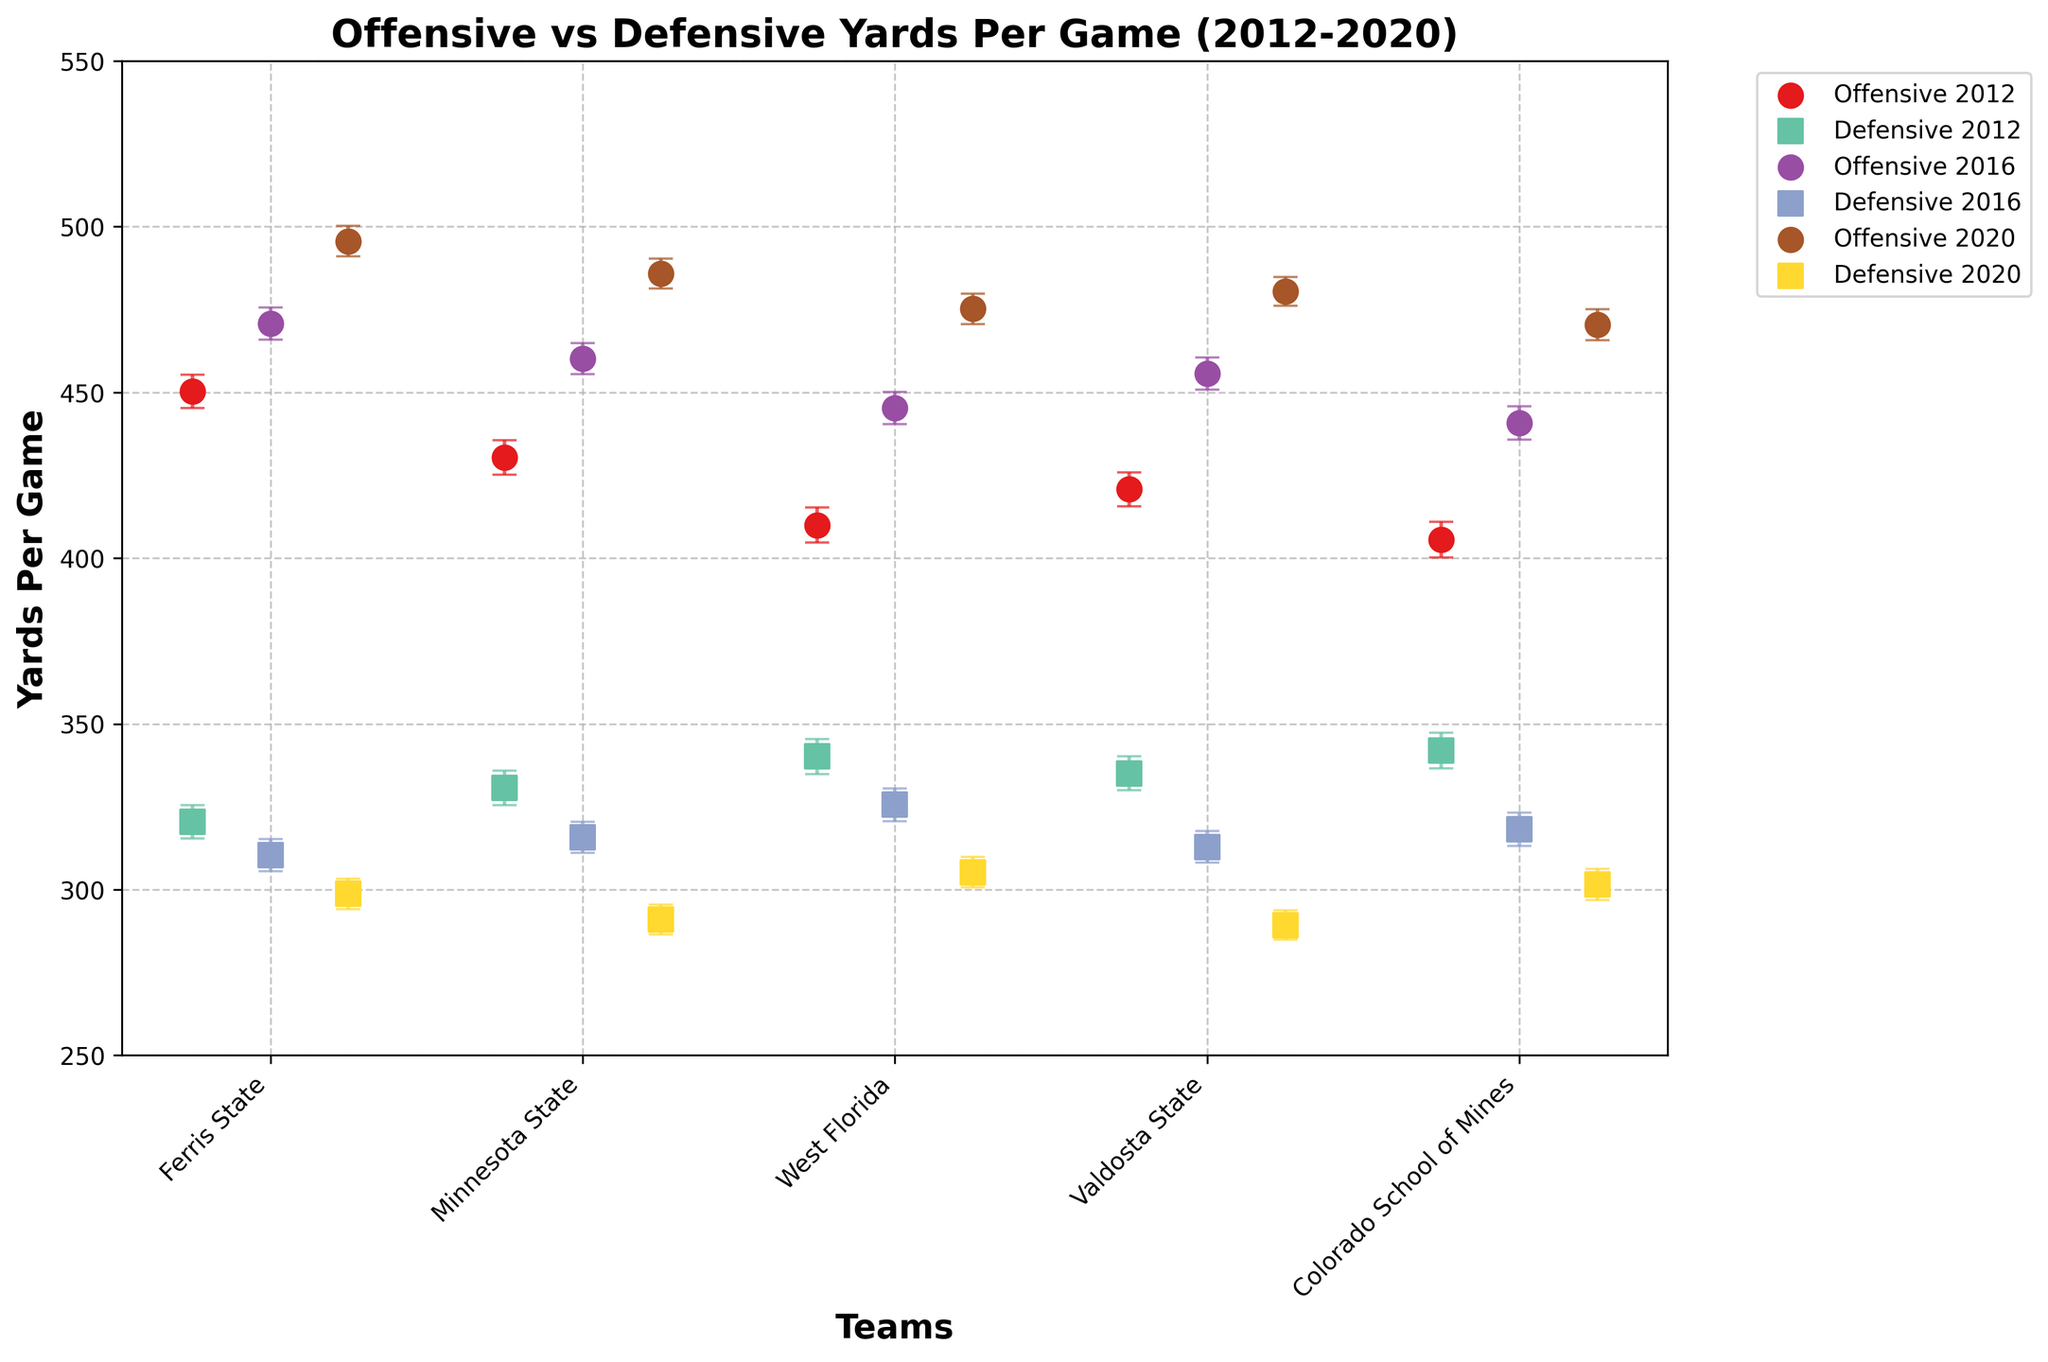Which team had the highest offensive yards per game in 2020? To find this, look at the scatter points representing offensive yards for the year 2020, usually marked differently (different color or shape). Compare the values for each team. The highest point corresponds to the highest offensive yards.
Answer: Ferris State Which team's defensive yards per game decreased most from 2012 to 2020? Identify the scatter points for defensive yards per game in 2012 and 2020 for each team. Calculate the difference for each team by subtracting the 2020 value from the 2012 value. The team with the highest positive difference had the most decrease.
Answer: Minnesota State What is the range of offensive yards per game for Valdosta State from 2012 to 2020? Identify the offensive yards per game scatter points for Valdosta State in the years 2012, 2016, and 2020. Find the minimum and maximum values. The range is the maximum value minus the minimum value.
Answer: 59.7 Which team shows the greatest variation in their offensive yards per game from 2012 to 2020? Look at the scatter points representing offensive yards for all available years for each team. Calculate the range (maximum - minimum) for each team. The team with the greatest range shows the greatest variation.
Answer: Ferris State Which team had higher defensive yards per game in 2016, Ferris State or Minnesota State? Compare the scatter points representing defensive yards for Ferris State and Minnesota State in 2016. Identify which point is higher.
Answer: Minnesota State For the year 2016, how much higher were West Florida's offensive yards per game compared to their defensive yards per game? Find the points representing West Florida's offensive and defensive yards in 2016. Subtract defensive yards from offensive yards for that year.
Answer: 119.7 What trend do you observe in Ferris State's offensive yards per game from 2012 to 2020? Observe the scatter points representing Ferris State's offensive yards for 2012, 2016, and 2020. Notice the pattern of increase or decrease over these years.
Answer: Increasing For Colorado School of Mines in 2020, how does the defensive yards per game compare to their offensive yards per game? Look at the 2020 points representing Colorado School of Mines for offensive and defensive yards. Compare their values.
Answer: Lower 